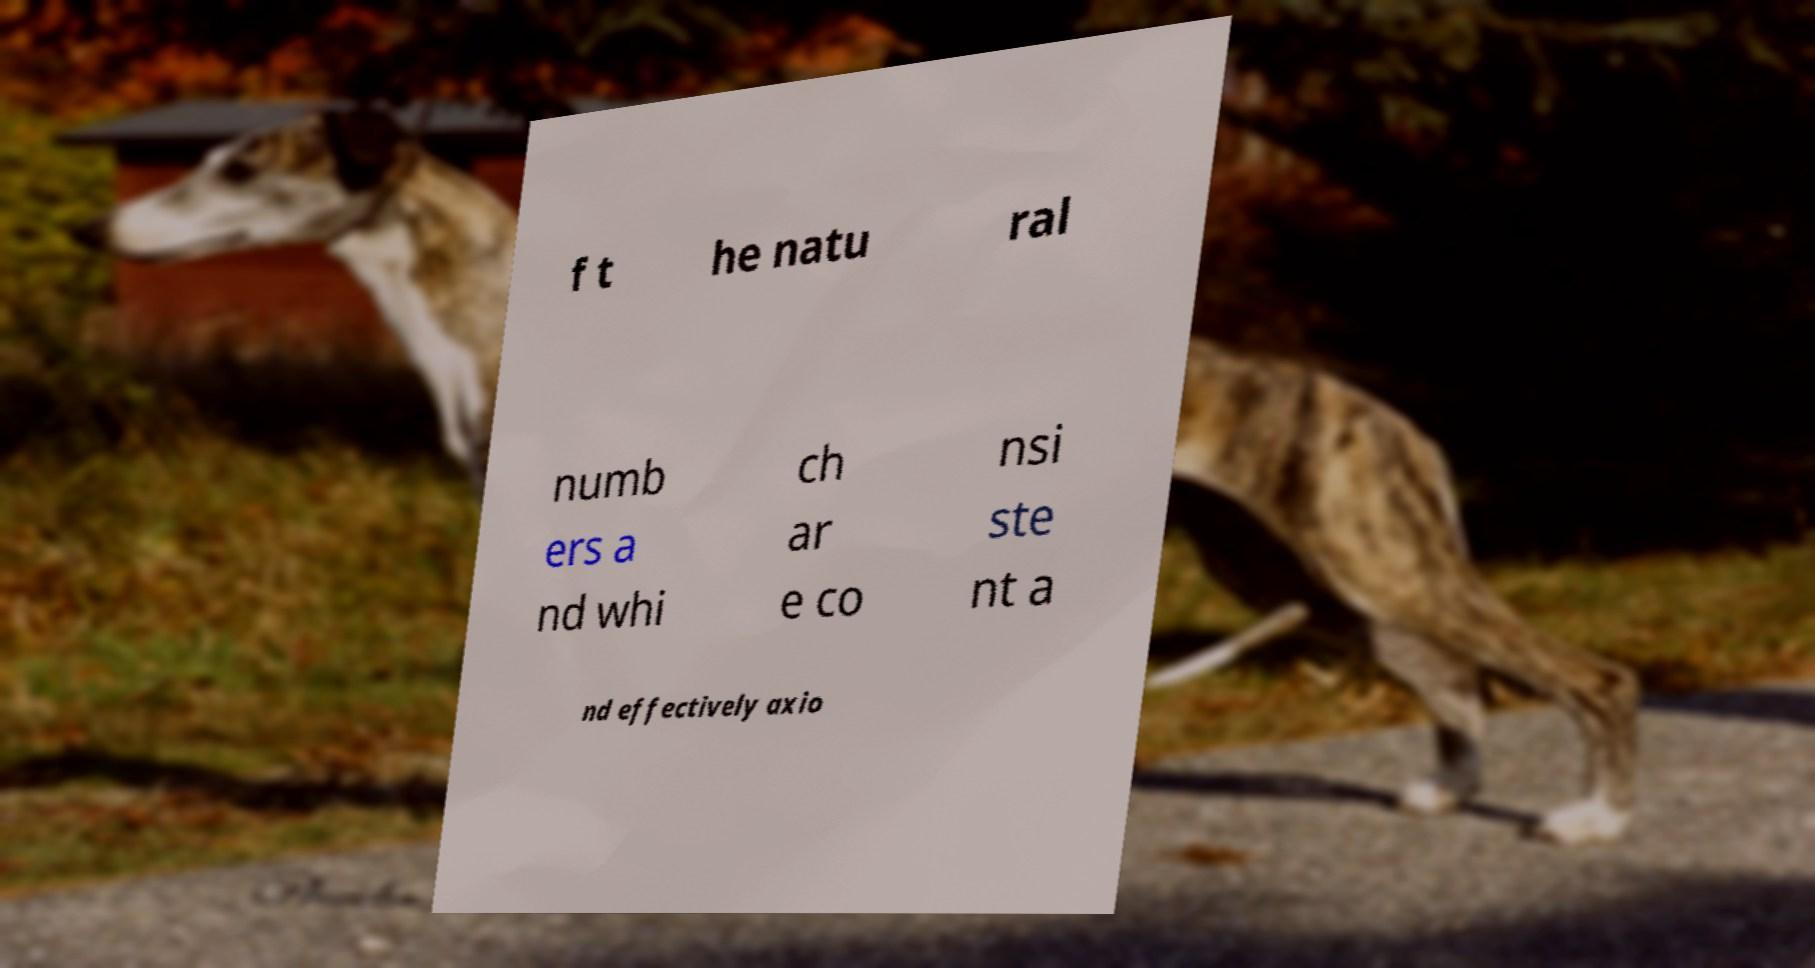Can you accurately transcribe the text from the provided image for me? f t he natu ral numb ers a nd whi ch ar e co nsi ste nt a nd effectively axio 